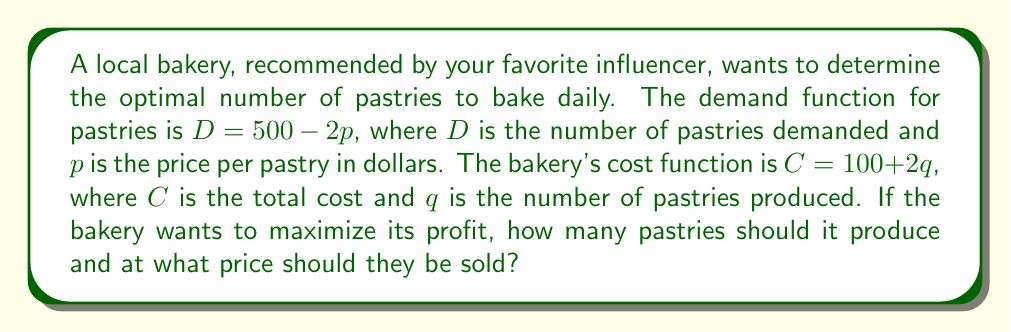Provide a solution to this math problem. Let's approach this step-by-step:

1) First, we need to find the revenue function. Revenue is price times quantity:
   $R = pq$

2) We know that at equilibrium, quantity demanded equals quantity supplied:
   $q = D = 500 - 2p$

3) Substituting this into the revenue function:
   $R = p(500 - 2p) = 500p - 2p^2$

4) Profit is revenue minus cost:
   $P = R - C = (500p - 2p^2) - (100 + 2q)$
   $P = 500p - 2p^2 - 100 - 2(500 - 2p)$
   $P = 500p - 2p^2 - 100 - 1000 + 4p$
   $P = -2p^2 + 504p - 1100$

5) To maximize profit, we find where the derivative of P with respect to p is zero:
   $\frac{dP}{dp} = -4p + 504 = 0$
   $4p = 504$
   $p = 126$

6) Now we can find q by substituting p back into the demand function:
   $q = 500 - 2(126) = 248$

7) To verify this is a maximum, we can check that the second derivative is negative:
   $\frac{d^2P}{dp^2} = -4$, which is indeed negative.

Therefore, the bakery should produce 248 pastries and sell them at $126 each to maximize profit.
Answer: 248 pastries at $126 each 